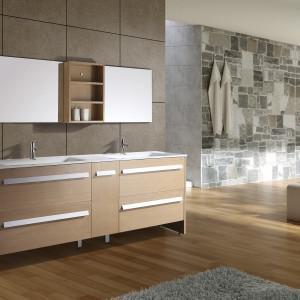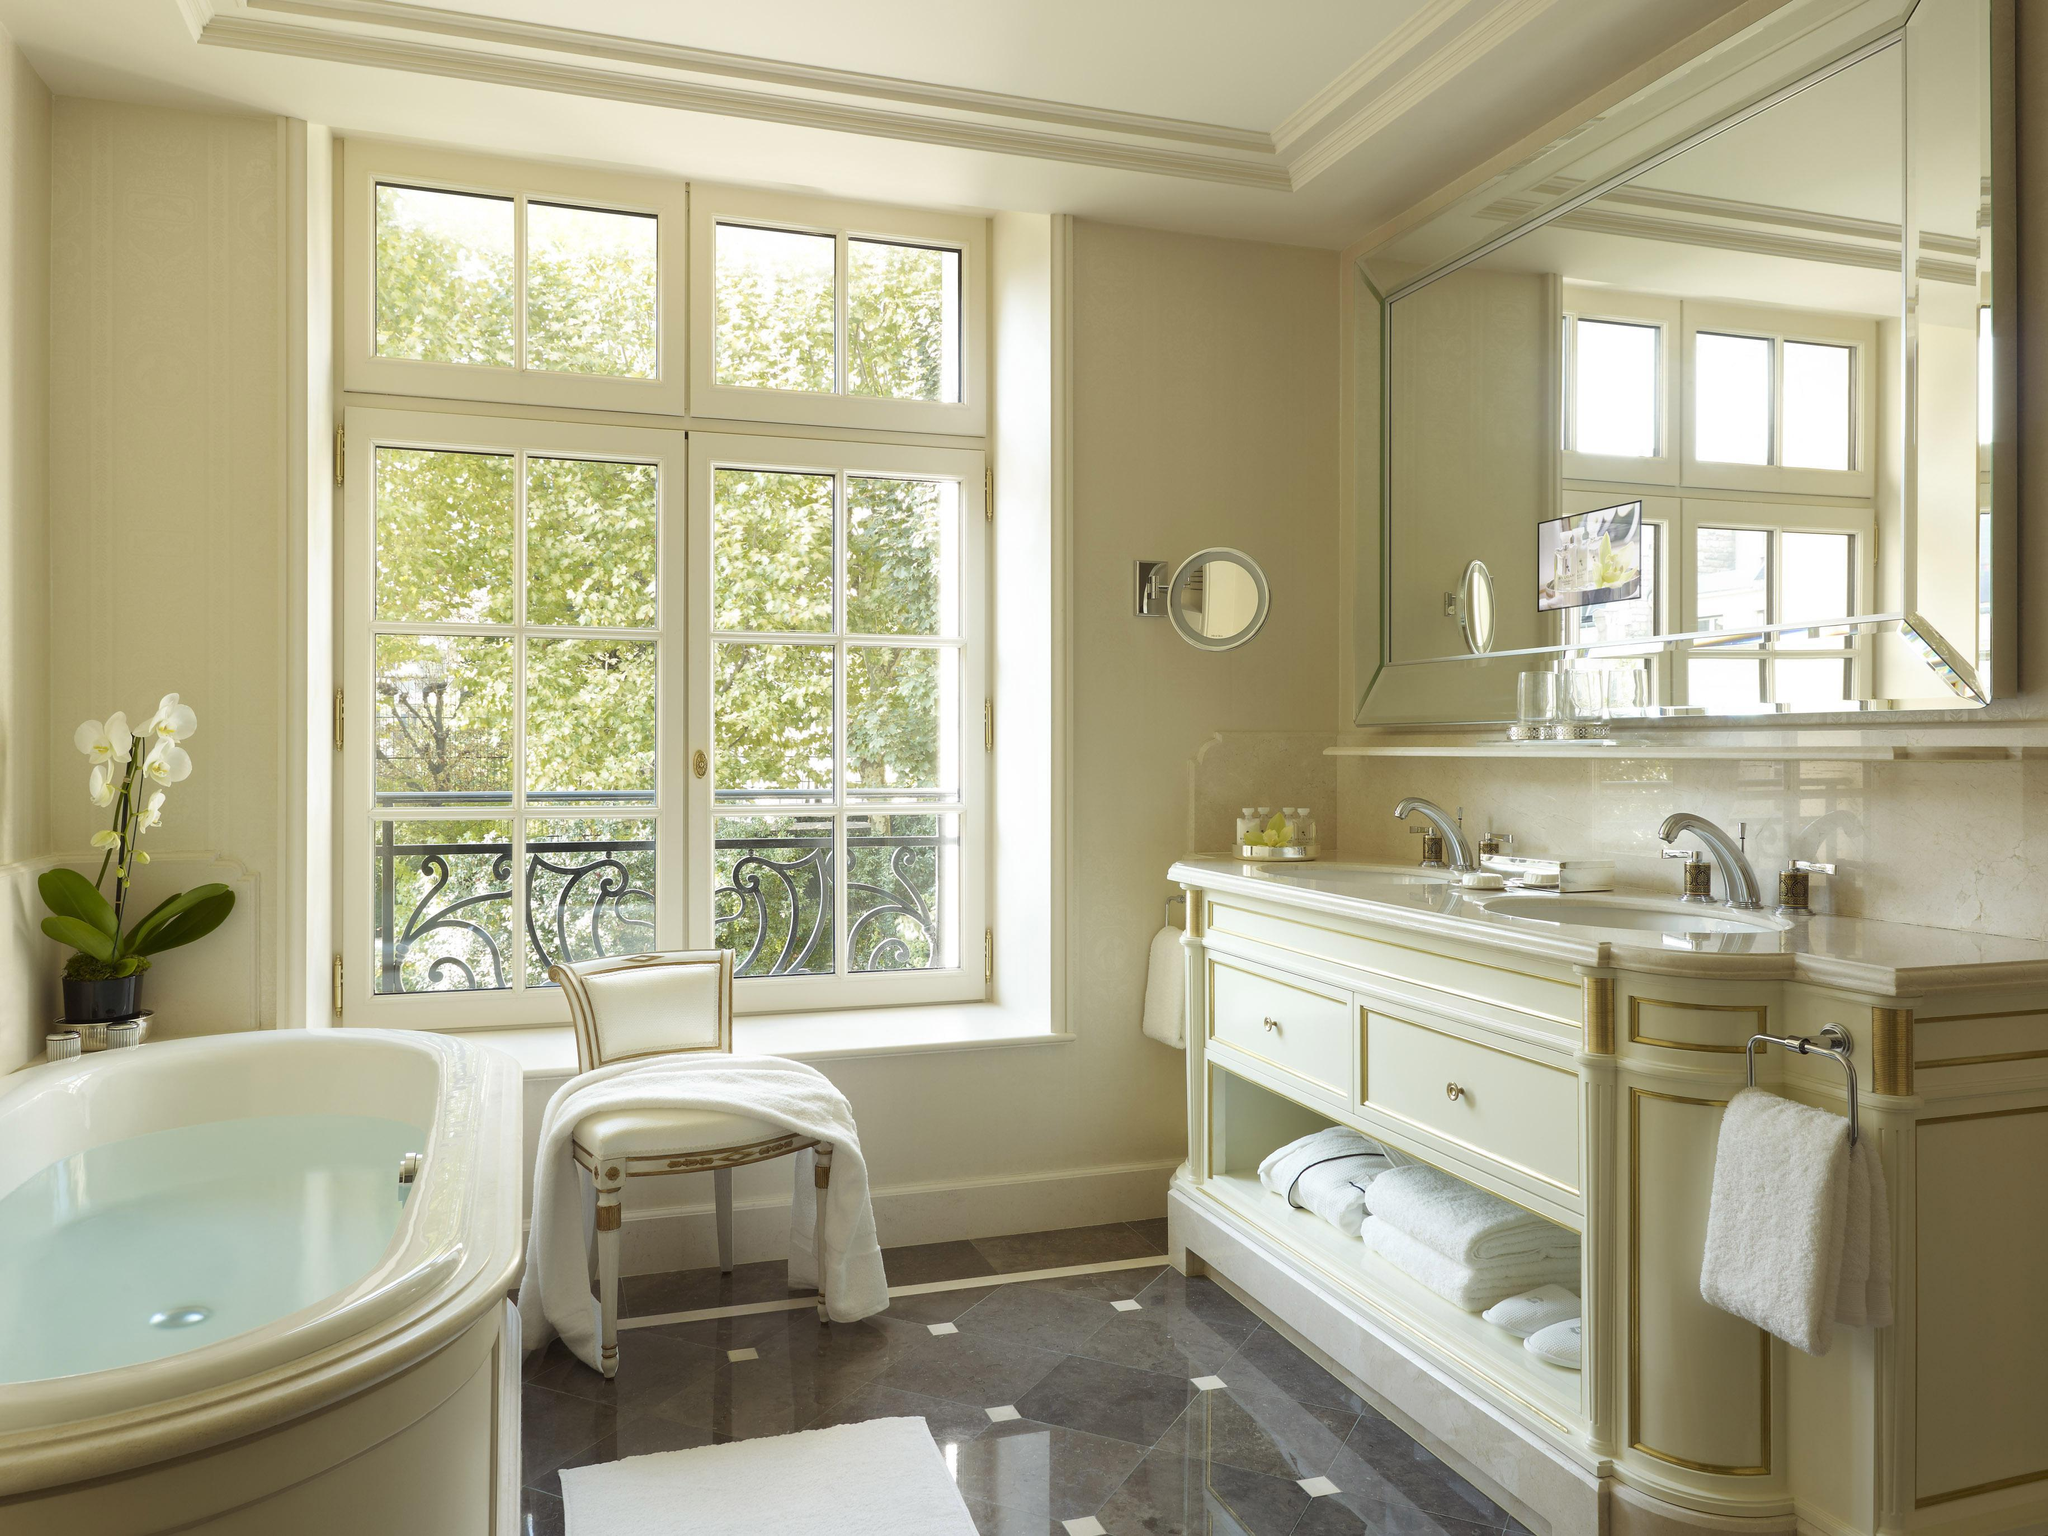The first image is the image on the left, the second image is the image on the right. For the images shown, is this caption "Left and right images each show one long counter with two separate sinks displayed at similar angles, and the counter on the right has at least one woven basket under it." true? Answer yes or no. No. 